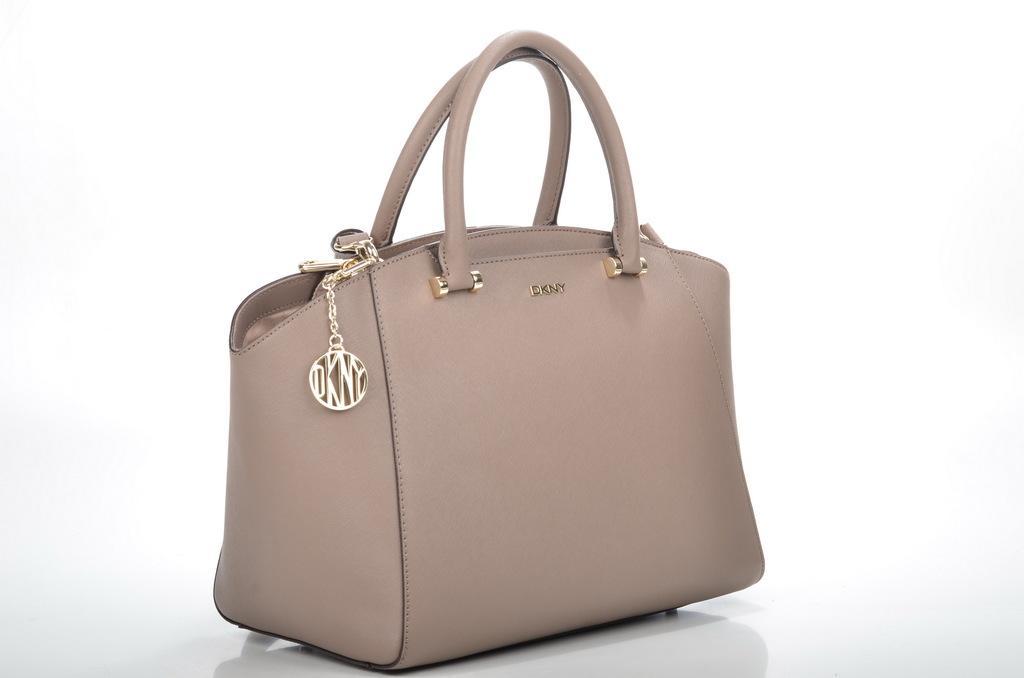Can you describe this image briefly? This is an image with white colour back ground and there is a bag some text written on the bag. And there a chain attached to the bag. 